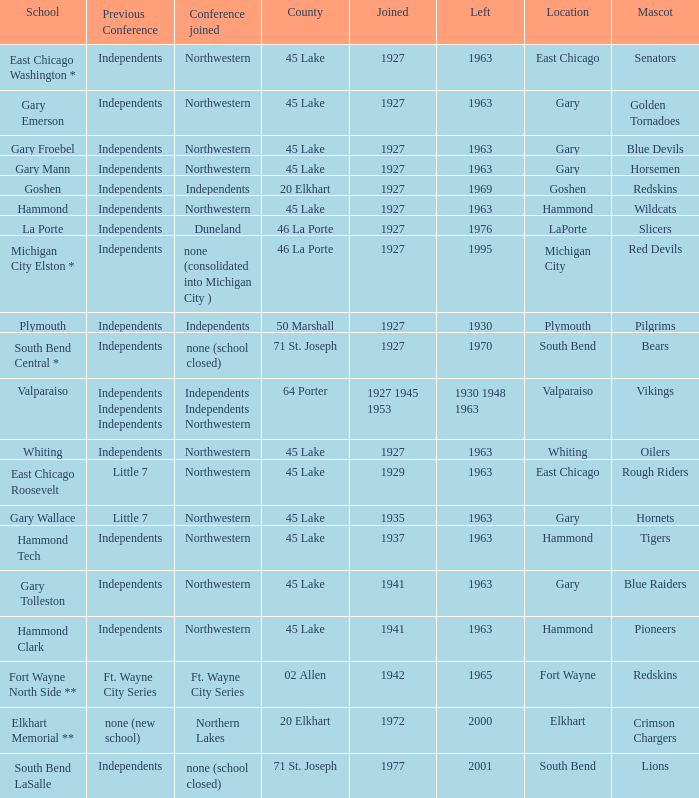Which conference held at School of whiting? Independents. 